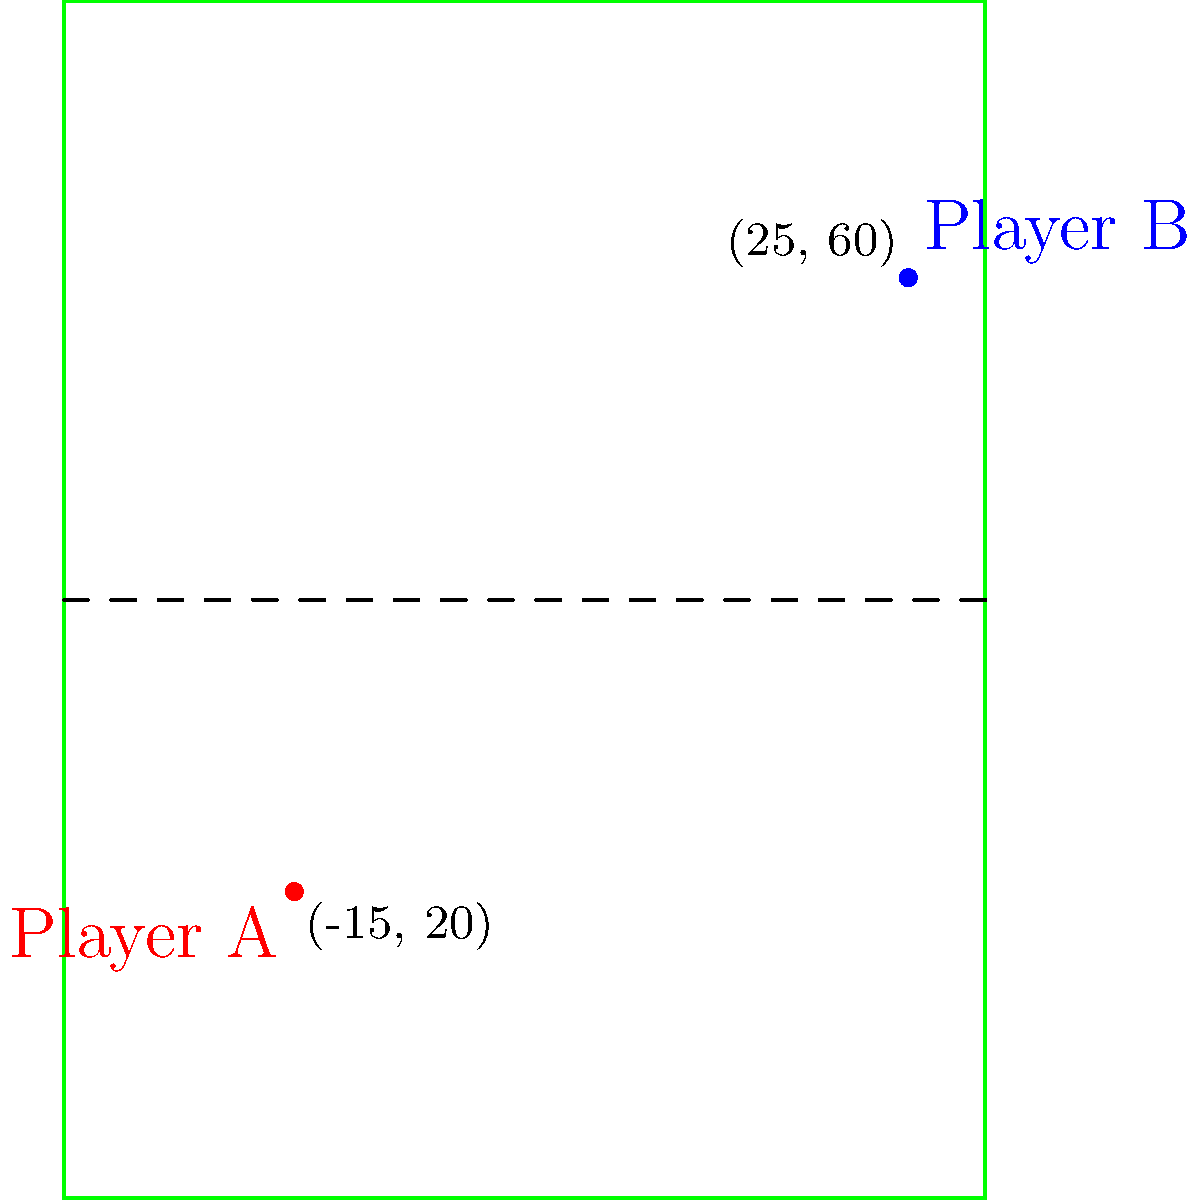In a women's tennis match, Player A is positioned at coordinates (-15, 20) and Player B is at (25, 60) on the court, as shown in the diagram. Using the distance formula, calculate the distance between the two players to the nearest tenth of a unit. How might this information be useful in analyzing player positioning and movement patterns in women's tennis? To solve this problem, we'll use the distance formula and then discuss its relevance to women's tennis analysis:

1) The distance formula is derived from the Pythagorean theorem:
   $$d = \sqrt{(x_2-x_1)^2 + (y_2-y_1)^2}$$

2) Given coordinates:
   Player A: $(x_1, y_1) = (-15, 20)$
   Player B: $(x_2, y_2) = (25, 60)$

3) Plug these into the formula:
   $$d = \sqrt{(25-(-15))^2 + (60-20)^2}$$

4) Simplify inside the parentheses:
   $$d = \sqrt{(40)^2 + (40)^2}$$

5) Calculate the squares:
   $$d = \sqrt{1600 + 1600}$$

6) Add under the square root:
   $$d = \sqrt{3200}$$

7) Simplify:
   $$d \approx 56.6$$

8) Round to the nearest tenth:
   $$d \approx 56.6$$

This information is valuable in analyzing women's tennis for several reasons:
- It helps in understanding court coverage and player positioning strategies.
- Coaches can use this data to optimize movement patterns and improve player efficiency.
- It aids in analyzing the effectiveness of different playing styles in women's tennis.
- This type of analysis contributes to the growing field of sports analytics, promoting data-driven approaches in women's sports.
Answer: 56.6 units 